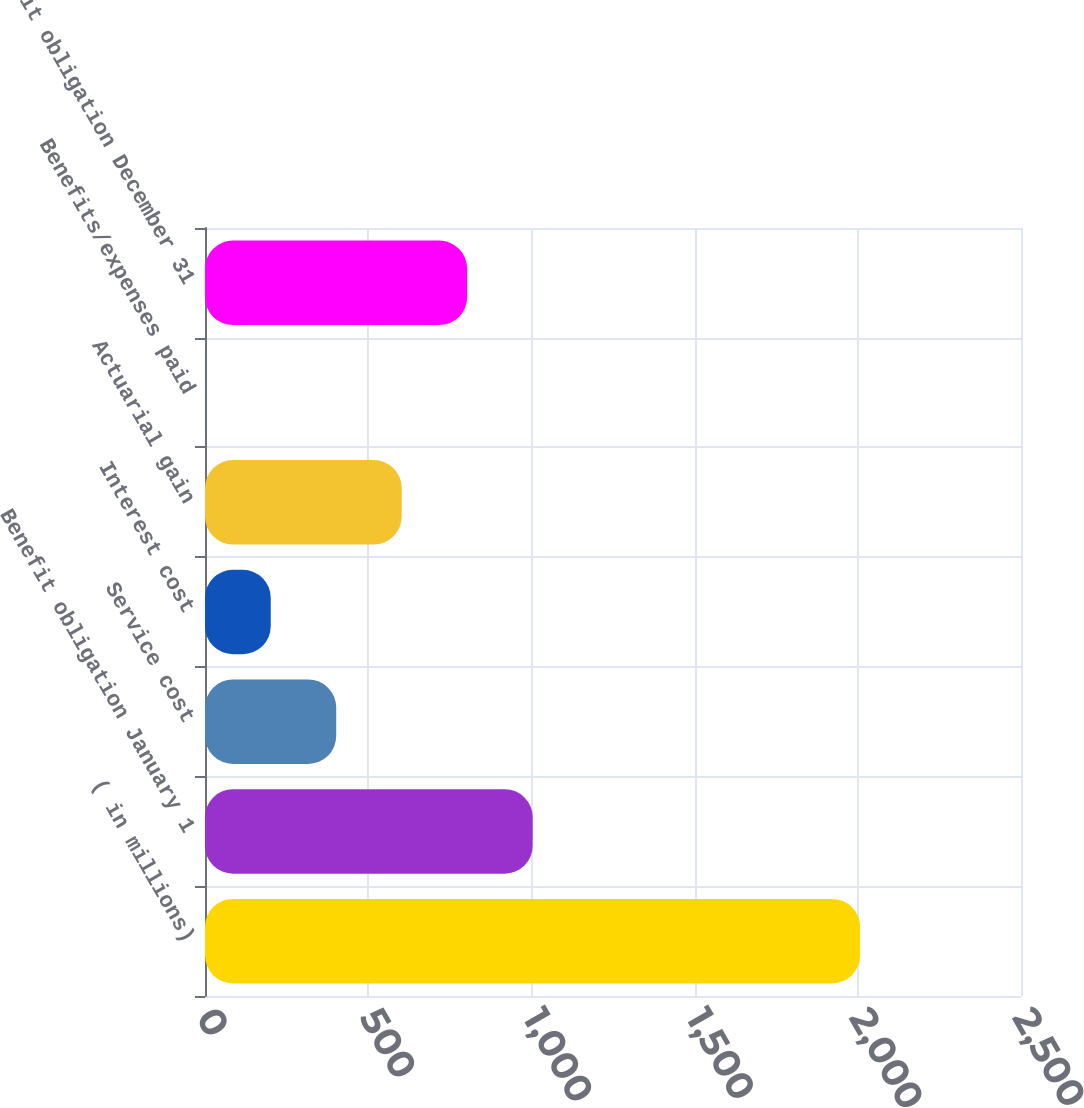Convert chart. <chart><loc_0><loc_0><loc_500><loc_500><bar_chart><fcel>( in millions)<fcel>Benefit obligation January 1<fcel>Service cost<fcel>Interest cost<fcel>Actuarial gain<fcel>Benefits/expenses paid<fcel>Benefit obligation December 31<nl><fcel>2007<fcel>1003.9<fcel>402.04<fcel>201.42<fcel>602.66<fcel>0.8<fcel>803.28<nl></chart> 